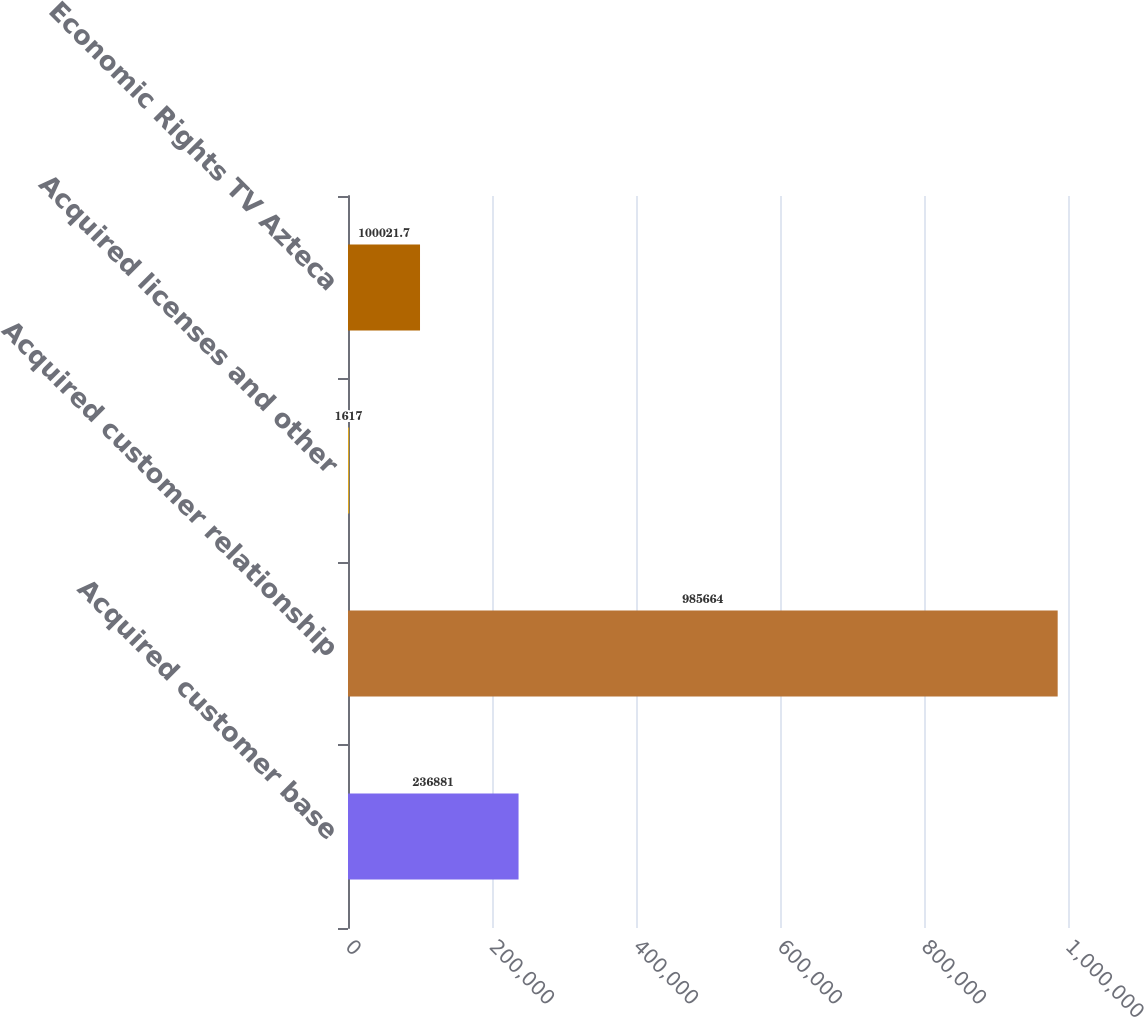Convert chart to OTSL. <chart><loc_0><loc_0><loc_500><loc_500><bar_chart><fcel>Acquired customer base<fcel>Acquired customer relationship<fcel>Acquired licenses and other<fcel>Economic Rights TV Azteca<nl><fcel>236881<fcel>985664<fcel>1617<fcel>100022<nl></chart> 